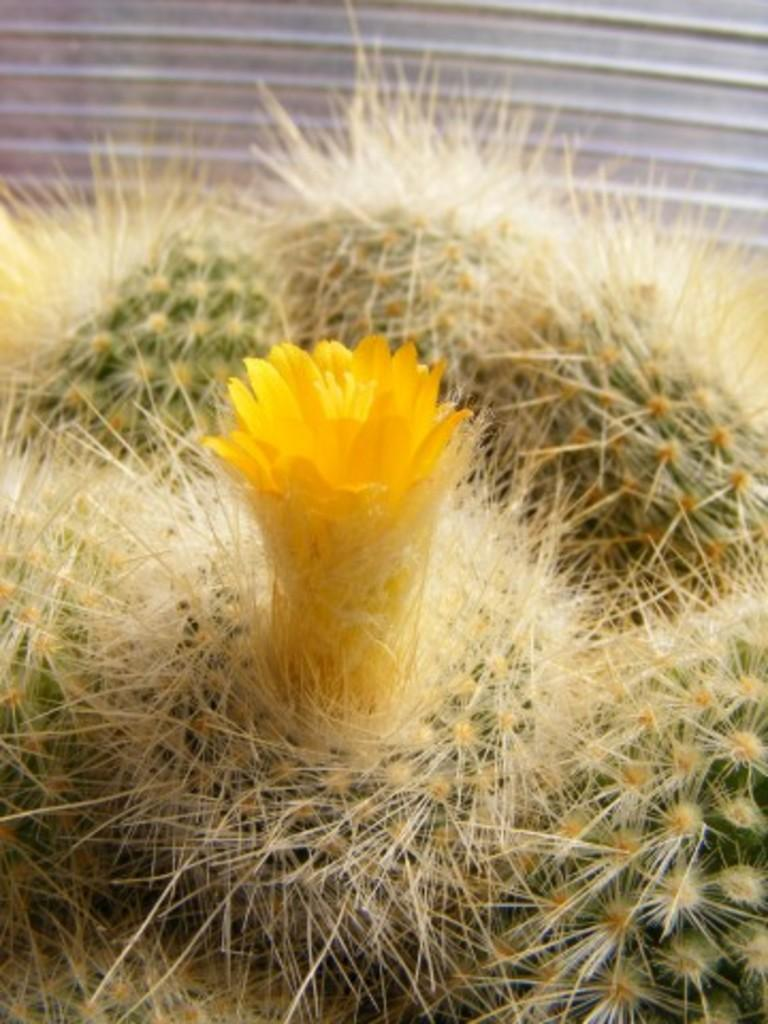What is present in the image? There is a plant in the image. What can be observed about the plant? The plant has a yellow flower. What type of reaction does the plant have to the sticks in the image? There are no sticks present in the image, so the plant does not have a reaction to them. What is the nose of the plant like in the image? Plants do not have noses, so this detail cannot be observed in the image. 